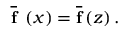<formula> <loc_0><loc_0><loc_500><loc_500>\ \overline { f } \ \left ( x \right ) = \overline { f } \left ( z \right ) .</formula> 